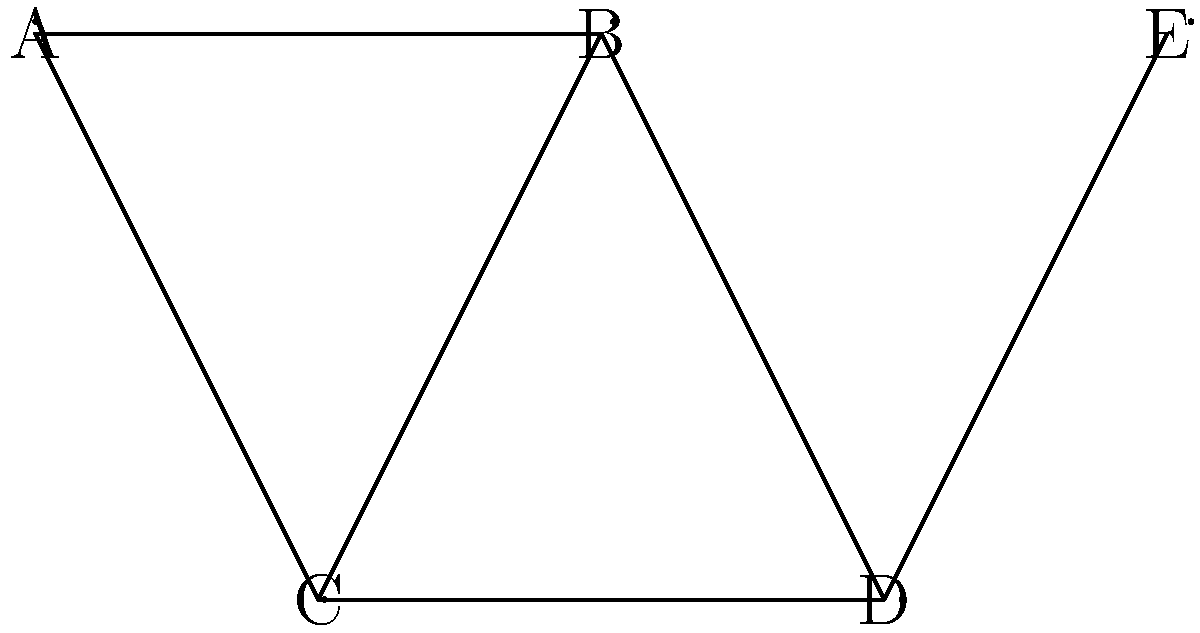In the network topology shown above, which node, if removed, would have the most significant impact on the network's connectivity and reliability? Justify your answer using graph theory concepts. To determine which node would have the most significant impact on the network's connectivity and reliability, we need to analyze the graph's structure and consider several factors:

1. Node degree: The degree of a node is the number of edges connected to it. Higher degree nodes are often more critical.
   - A: degree 2
   - B: degree 3
   - C: degree 3
   - D: degree 3
   - E: degree 1

2. Centrality: Nodes that act as bridges between different parts of the network are more important.

3. Network partitioning: Removing a node that splits the network into disconnected components has a severe impact.

4. Redundant paths: Consider alternative paths that remain after node removal.

Analyzing each node:

A: Removing A would leave B-C-D-E connected. Impact is relatively low.

B: Removing B would disconnect A from the rest of the network and reduce redundancy between C and D. High impact.

C: Removing C would reduce redundancy but maintain overall connectivity. Moderate impact.

D: Removing D would disconnect E from the rest of the network and reduce redundancy between B and C. High impact.

E: Removing E is the least impactful as it's a leaf node.

The most critical nodes are B and D. However, D is slightly more critical because:
1. It's the only connection point for E.
2. Its removal would create a longer path between B and C, reducing efficiency.
3. It acts as a bridge between the dense part of the network (A-B-C) and the edge (E).

Therefore, removing node D would have the most significant impact on the network's connectivity and reliability.
Answer: Node D 